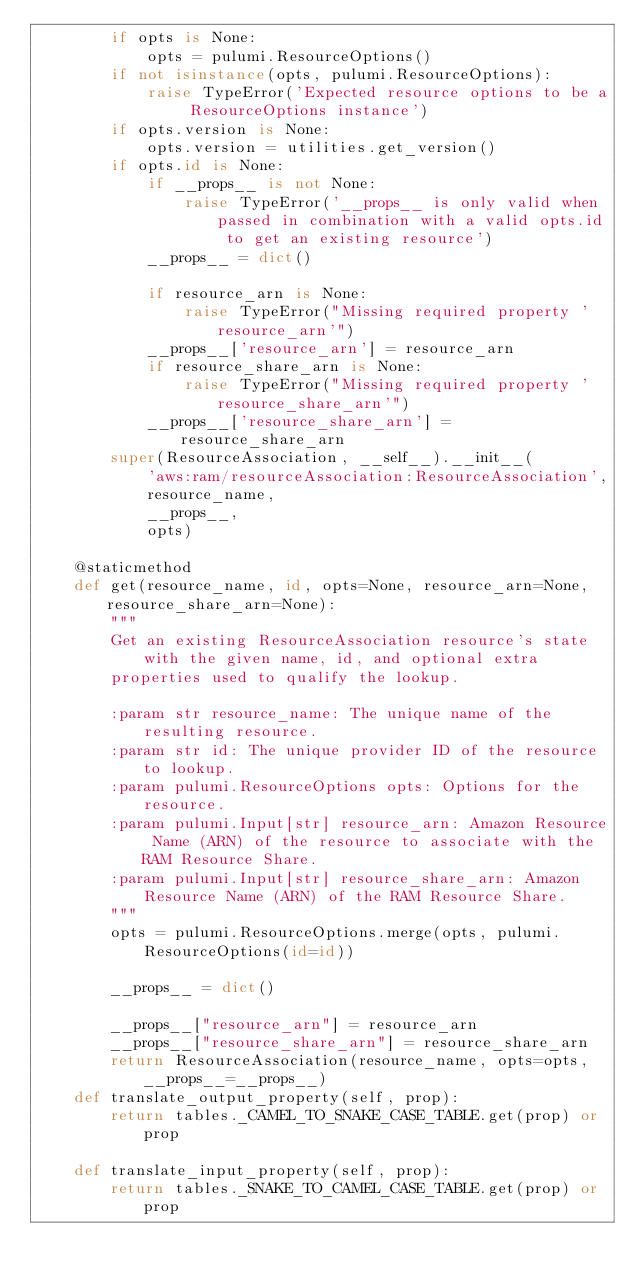<code> <loc_0><loc_0><loc_500><loc_500><_Python_>        if opts is None:
            opts = pulumi.ResourceOptions()
        if not isinstance(opts, pulumi.ResourceOptions):
            raise TypeError('Expected resource options to be a ResourceOptions instance')
        if opts.version is None:
            opts.version = utilities.get_version()
        if opts.id is None:
            if __props__ is not None:
                raise TypeError('__props__ is only valid when passed in combination with a valid opts.id to get an existing resource')
            __props__ = dict()

            if resource_arn is None:
                raise TypeError("Missing required property 'resource_arn'")
            __props__['resource_arn'] = resource_arn
            if resource_share_arn is None:
                raise TypeError("Missing required property 'resource_share_arn'")
            __props__['resource_share_arn'] = resource_share_arn
        super(ResourceAssociation, __self__).__init__(
            'aws:ram/resourceAssociation:ResourceAssociation',
            resource_name,
            __props__,
            opts)

    @staticmethod
    def get(resource_name, id, opts=None, resource_arn=None, resource_share_arn=None):
        """
        Get an existing ResourceAssociation resource's state with the given name, id, and optional extra
        properties used to qualify the lookup.

        :param str resource_name: The unique name of the resulting resource.
        :param str id: The unique provider ID of the resource to lookup.
        :param pulumi.ResourceOptions opts: Options for the resource.
        :param pulumi.Input[str] resource_arn: Amazon Resource Name (ARN) of the resource to associate with the RAM Resource Share.
        :param pulumi.Input[str] resource_share_arn: Amazon Resource Name (ARN) of the RAM Resource Share.
        """
        opts = pulumi.ResourceOptions.merge(opts, pulumi.ResourceOptions(id=id))

        __props__ = dict()

        __props__["resource_arn"] = resource_arn
        __props__["resource_share_arn"] = resource_share_arn
        return ResourceAssociation(resource_name, opts=opts, __props__=__props__)
    def translate_output_property(self, prop):
        return tables._CAMEL_TO_SNAKE_CASE_TABLE.get(prop) or prop

    def translate_input_property(self, prop):
        return tables._SNAKE_TO_CAMEL_CASE_TABLE.get(prop) or prop

</code> 